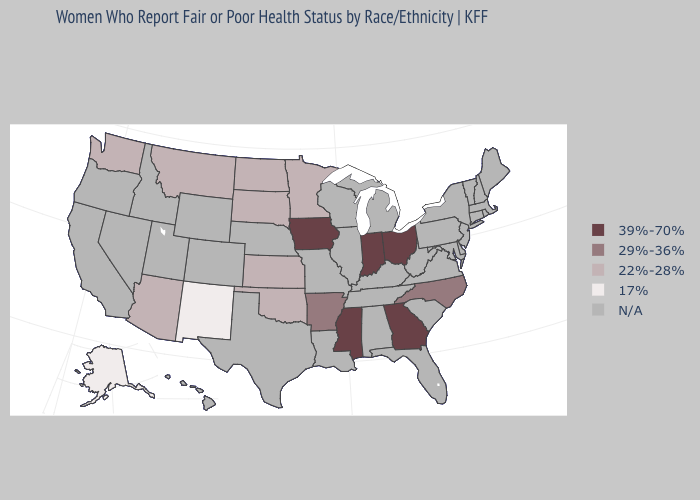Name the states that have a value in the range 17%?
Quick response, please. Alaska, New Mexico. Does the first symbol in the legend represent the smallest category?
Write a very short answer. No. Name the states that have a value in the range 39%-70%?
Answer briefly. Georgia, Indiana, Iowa, Mississippi, Ohio. What is the lowest value in the USA?
Quick response, please. 17%. How many symbols are there in the legend?
Be succinct. 5. What is the lowest value in the South?
Keep it brief. 22%-28%. Does Minnesota have the highest value in the USA?
Answer briefly. No. What is the highest value in the USA?
Be succinct. 39%-70%. Name the states that have a value in the range 39%-70%?
Short answer required. Georgia, Indiana, Iowa, Mississippi, Ohio. 